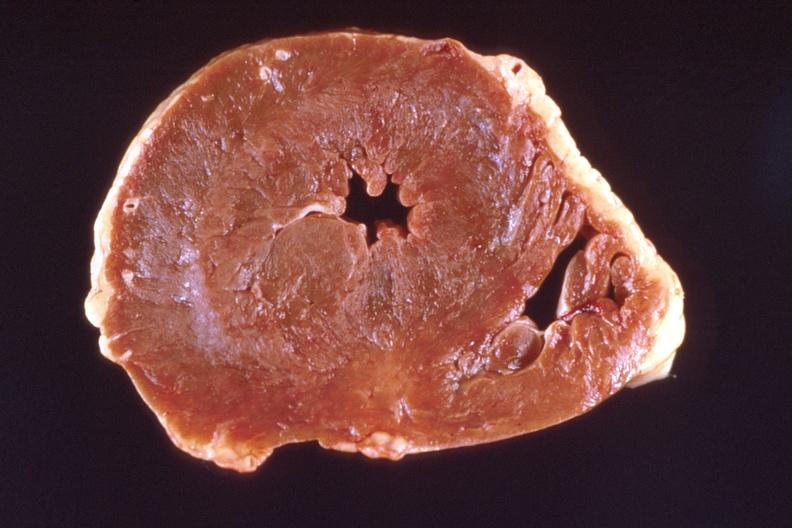what left ventricular hypertrophy?
Answer the question using a single word or phrase. Heart, marked 